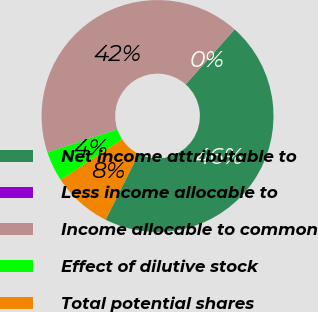<chart> <loc_0><loc_0><loc_500><loc_500><pie_chart><fcel>Net income attributable to<fcel>Less income allocable to<fcel>Income allocable to common<fcel>Effect of dilutive stock<fcel>Total potential shares<nl><fcel>45.81%<fcel>0.01%<fcel>41.65%<fcel>4.18%<fcel>8.34%<nl></chart> 